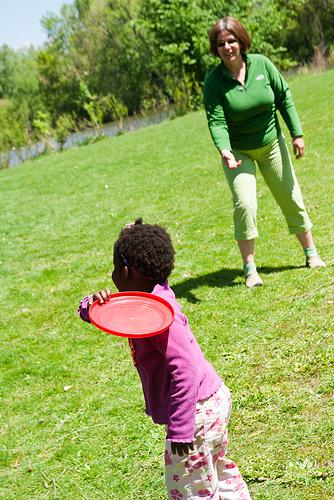Question: what color shirt is the girl wearing?
Choices:
A. Red.
B. White.
C. Blue.
D. Pink.
Answer with the letter. Answer: D Question: what sport is being played?
Choices:
A. Basketball.
B. Frisbee.
C. Football.
D. Baseball.
Answer with the letter. Answer: B 